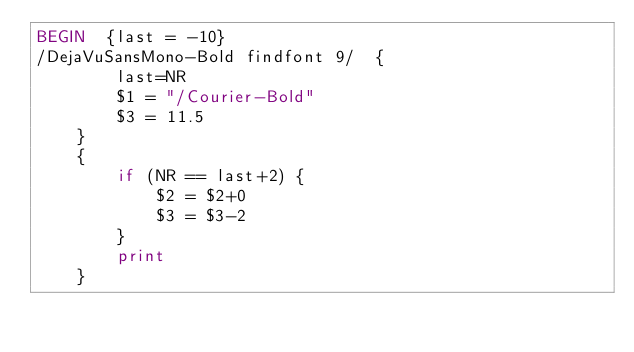Convert code to text. <code><loc_0><loc_0><loc_500><loc_500><_Awk_>BEGIN  {last = -10}
/DejaVuSansMono-Bold findfont 9/  {
        last=NR
        $1 = "/Courier-Bold"
        $3 = 11.5
    }
    {
        if (NR == last+2) {
            $2 = $2+0
            $3 = $3-2
        }
        print
    }
</code> 